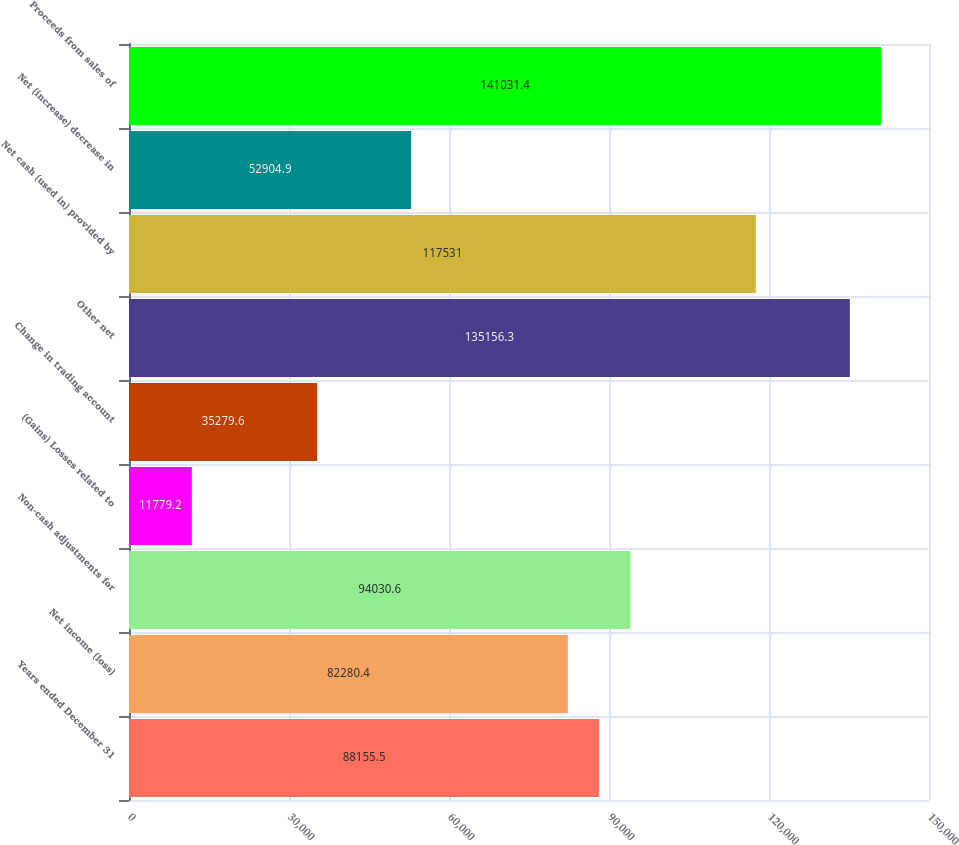Convert chart to OTSL. <chart><loc_0><loc_0><loc_500><loc_500><bar_chart><fcel>Years ended December 31<fcel>Net income (loss)<fcel>Non-cash adjustments for<fcel>(Gains) Losses related to<fcel>Change in trading account<fcel>Other net<fcel>Net cash (used in) provided by<fcel>Net (increase) decrease in<fcel>Proceeds from sales of<nl><fcel>88155.5<fcel>82280.4<fcel>94030.6<fcel>11779.2<fcel>35279.6<fcel>135156<fcel>117531<fcel>52904.9<fcel>141031<nl></chart> 